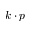Convert formula to latex. <formula><loc_0><loc_0><loc_500><loc_500>k \cdot p</formula> 